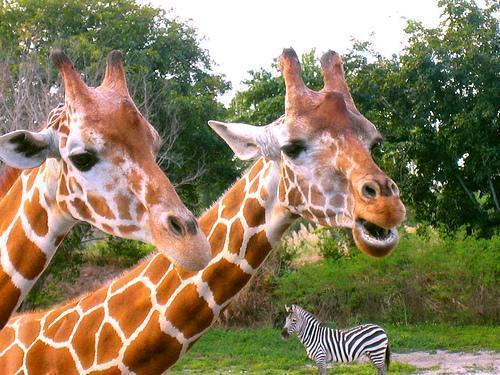What is in front of the zebra?
Indicate the correct response and explain using: 'Answer: answer
Rationale: rationale.'
Options: Dog, cat, cow, giraffe. Answer: giraffe.
Rationale: There are two giraffes standing in front of the zebra. 